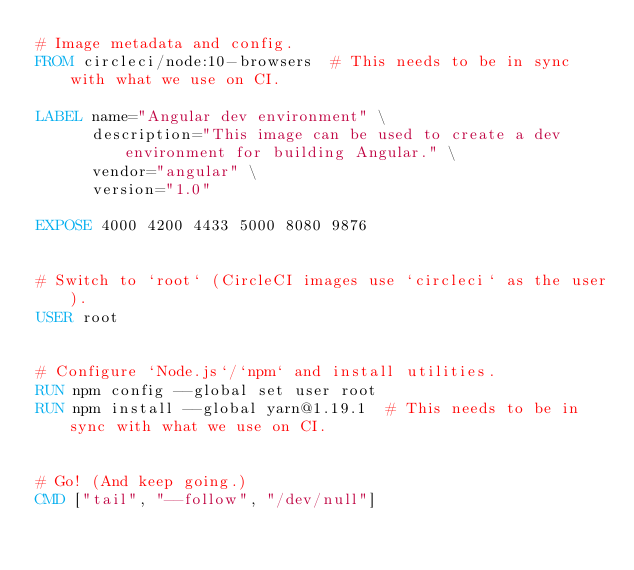<code> <loc_0><loc_0><loc_500><loc_500><_Dockerfile_># Image metadata and config.
FROM circleci/node:10-browsers  # This needs to be in sync with what we use on CI.

LABEL name="Angular dev environment" \
      description="This image can be used to create a dev environment for building Angular." \
      vendor="angular" \
      version="1.0"

EXPOSE 4000 4200 4433 5000 8080 9876


# Switch to `root` (CircleCI images use `circleci` as the user).
USER root


# Configure `Node.js`/`npm` and install utilities.
RUN npm config --global set user root
RUN npm install --global yarn@1.19.1  # This needs to be in sync with what we use on CI.


# Go! (And keep going.)
CMD ["tail", "--follow", "/dev/null"]
</code> 